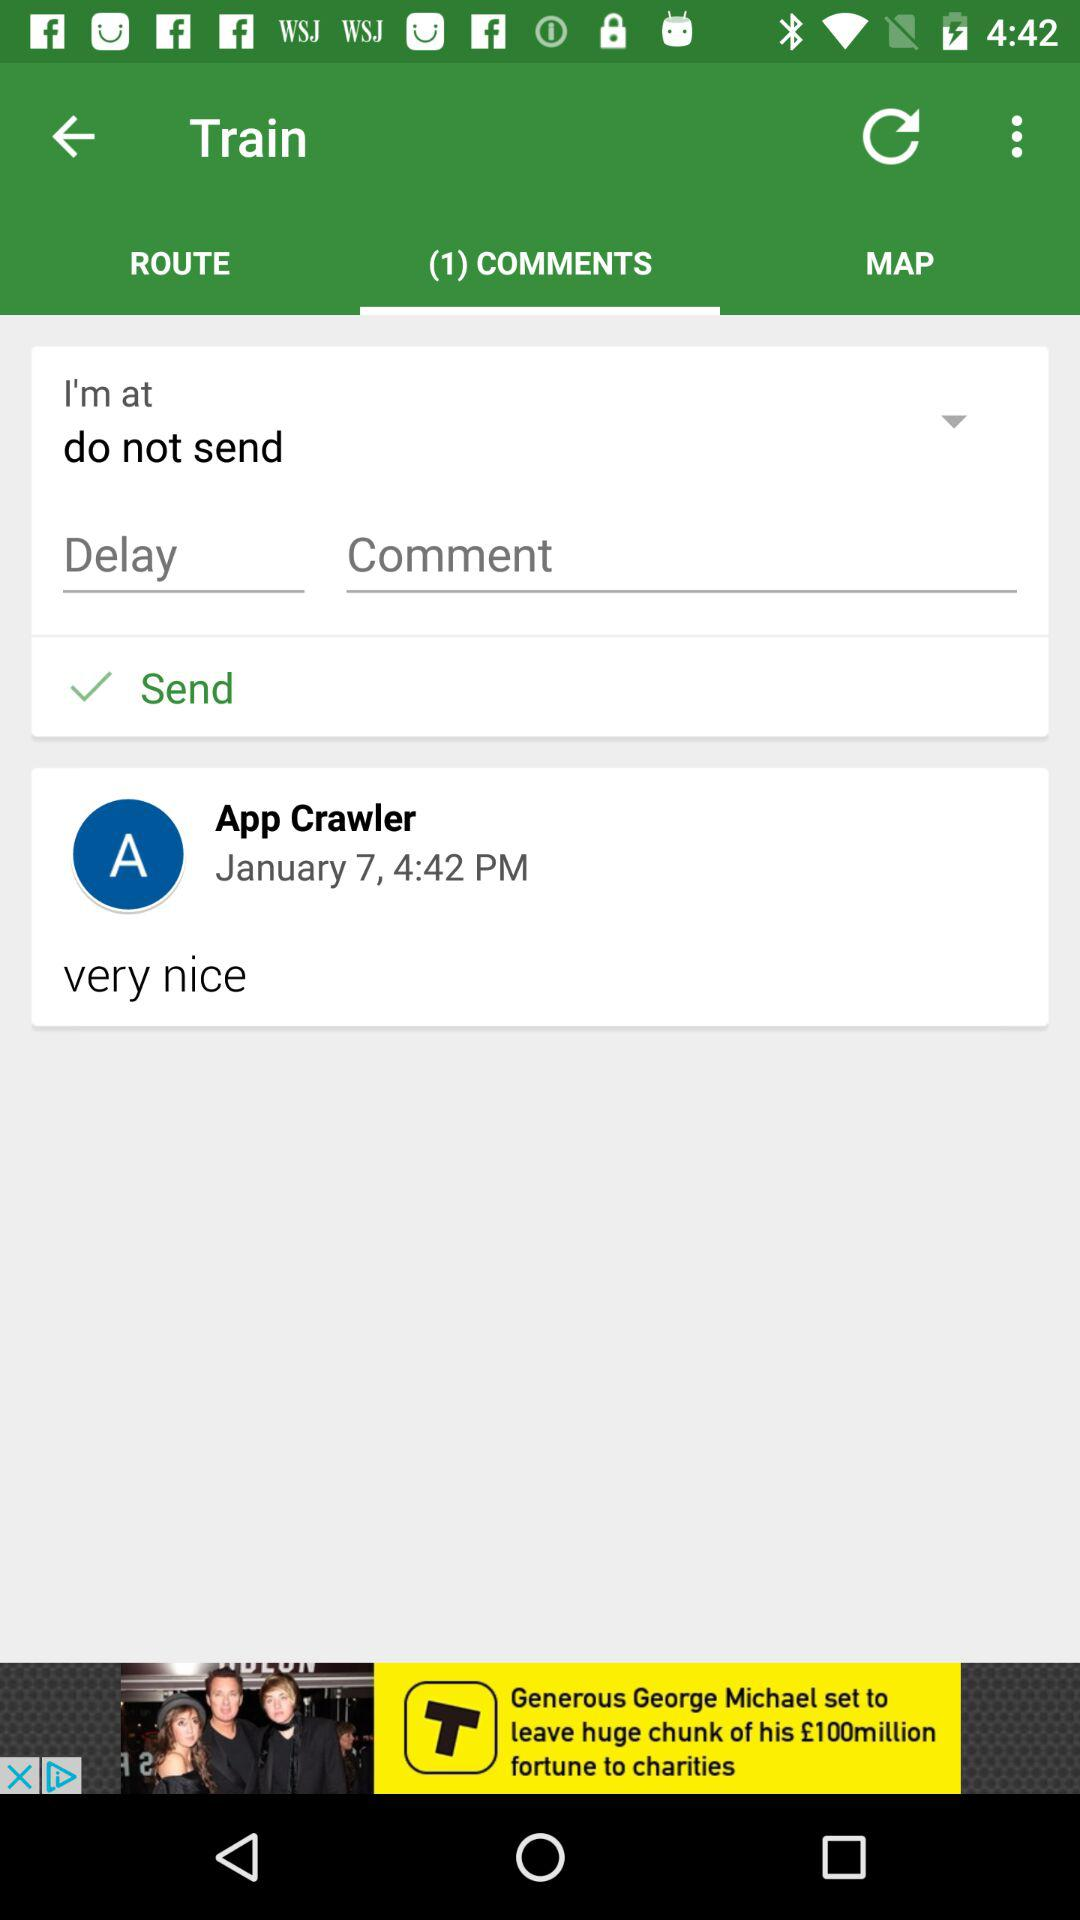How many comments are shown? There is 1 shown comment. 